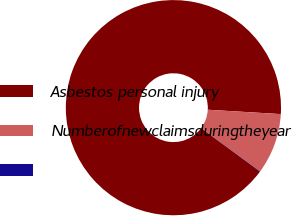Convert chart to OTSL. <chart><loc_0><loc_0><loc_500><loc_500><pie_chart><fcel>Asbestos personal injury<fcel>Numberofnewclaimsduringtheyear<fcel>Unnamed: 2<nl><fcel>90.85%<fcel>9.12%<fcel>0.04%<nl></chart> 